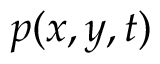<formula> <loc_0><loc_0><loc_500><loc_500>p ( x , y , t )</formula> 